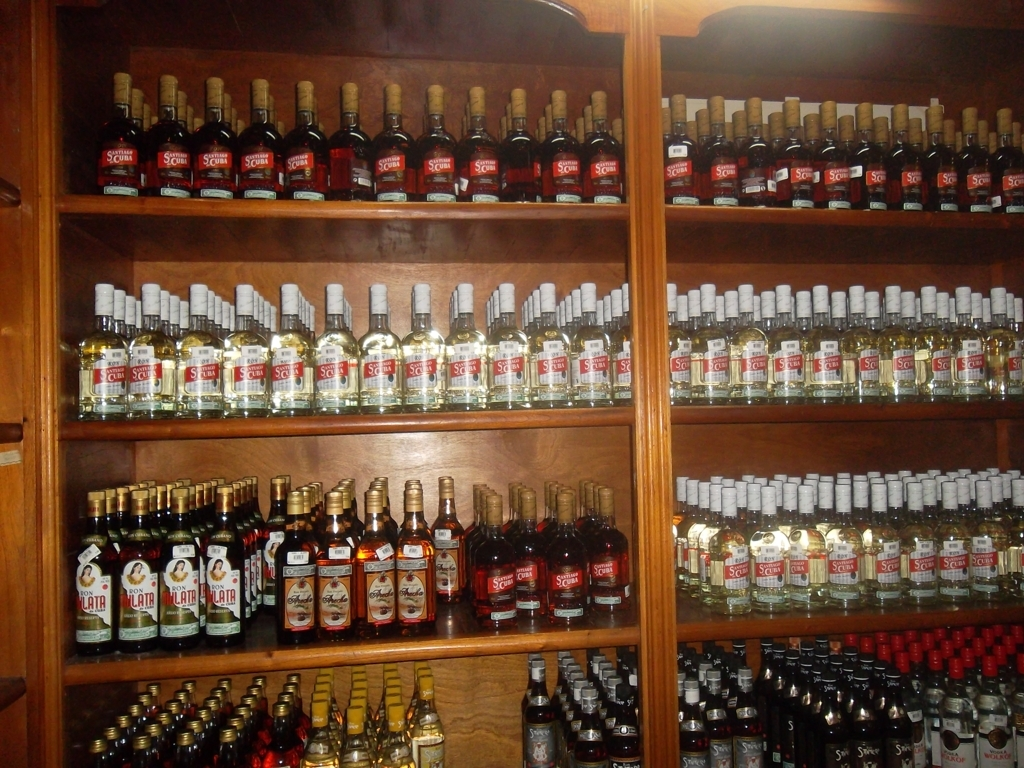Is the overall image clear?
A. Yes
B. No
Answer with the option's letter from the given choices directly.
 A. 